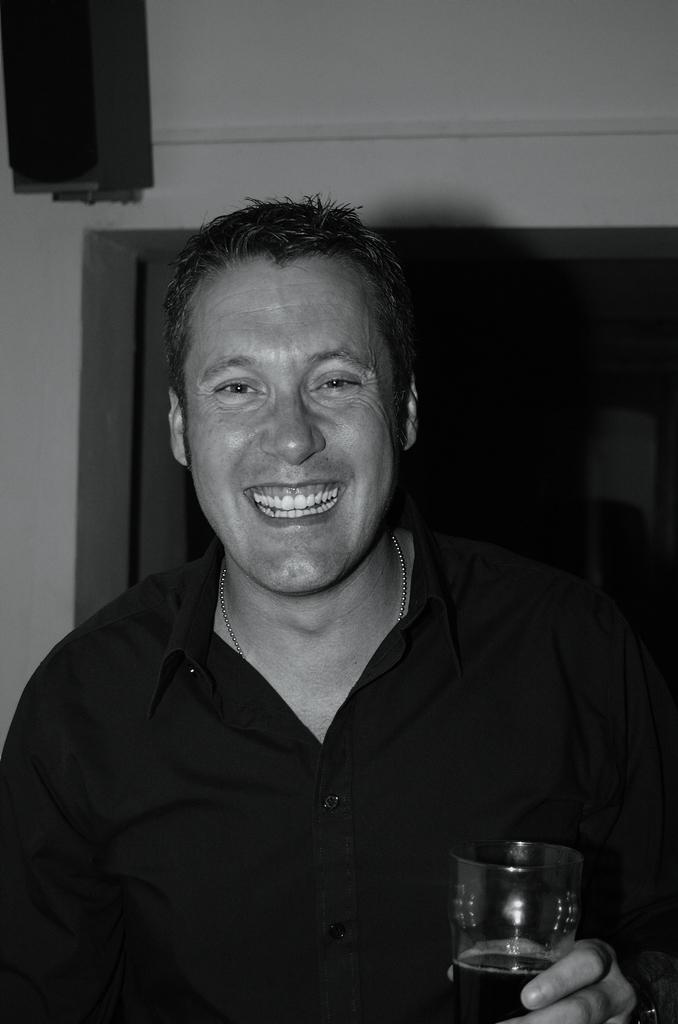What is the man in the image holding? The man is holding a glass. What is the man's facial expression in the image? The man is smiling. What can be seen in the background of the image? There is a wall, a speaker, and a door in the background of the image. How many sisters does the man have in the image? There is no information about the man's sisters in the image. What is the height of the snails on the wall in the image? There are no snails present in the image. 